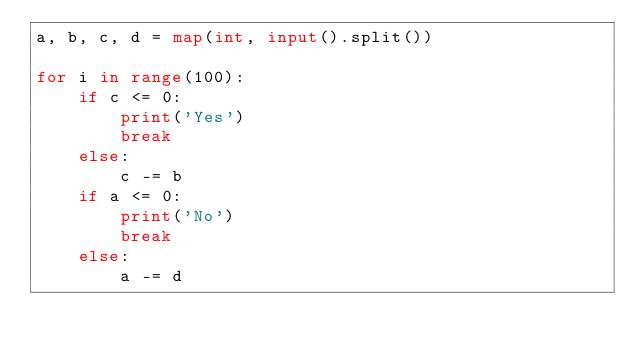<code> <loc_0><loc_0><loc_500><loc_500><_Python_>a, b, c, d = map(int, input().split())

for i in range(100):
    if c <= 0:
        print('Yes')
        break
    else:
        c -= b
    if a <= 0:
        print('No')
        break
    else:
        a -= d</code> 